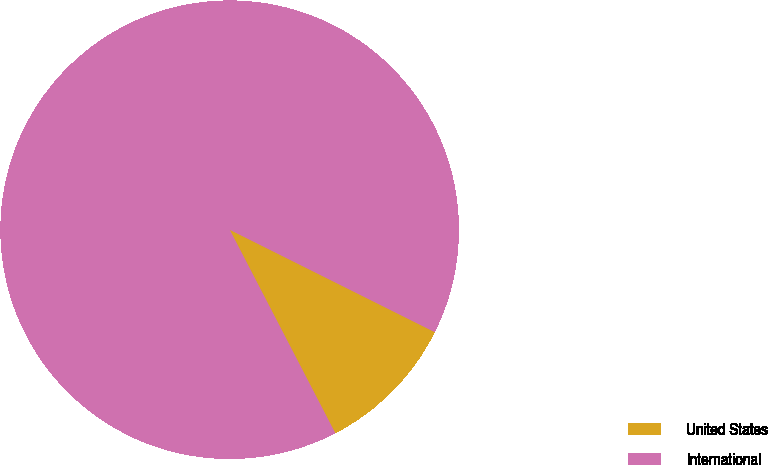Convert chart. <chart><loc_0><loc_0><loc_500><loc_500><pie_chart><fcel>United States<fcel>International<nl><fcel>10.01%<fcel>89.99%<nl></chart> 